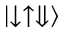<formula> <loc_0><loc_0><loc_500><loc_500>\left | \downarrow \uparrow \Downarrow \right \rangle</formula> 